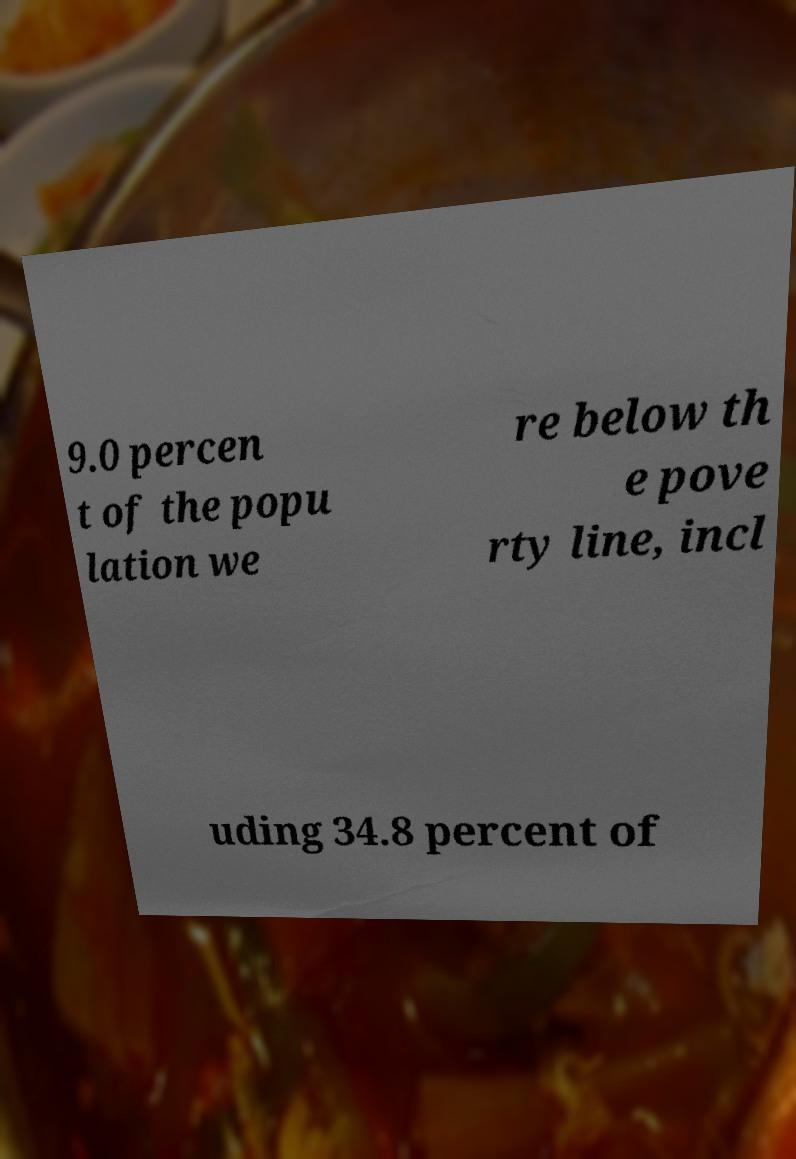Can you read and provide the text displayed in the image?This photo seems to have some interesting text. Can you extract and type it out for me? 9.0 percen t of the popu lation we re below th e pove rty line, incl uding 34.8 percent of 